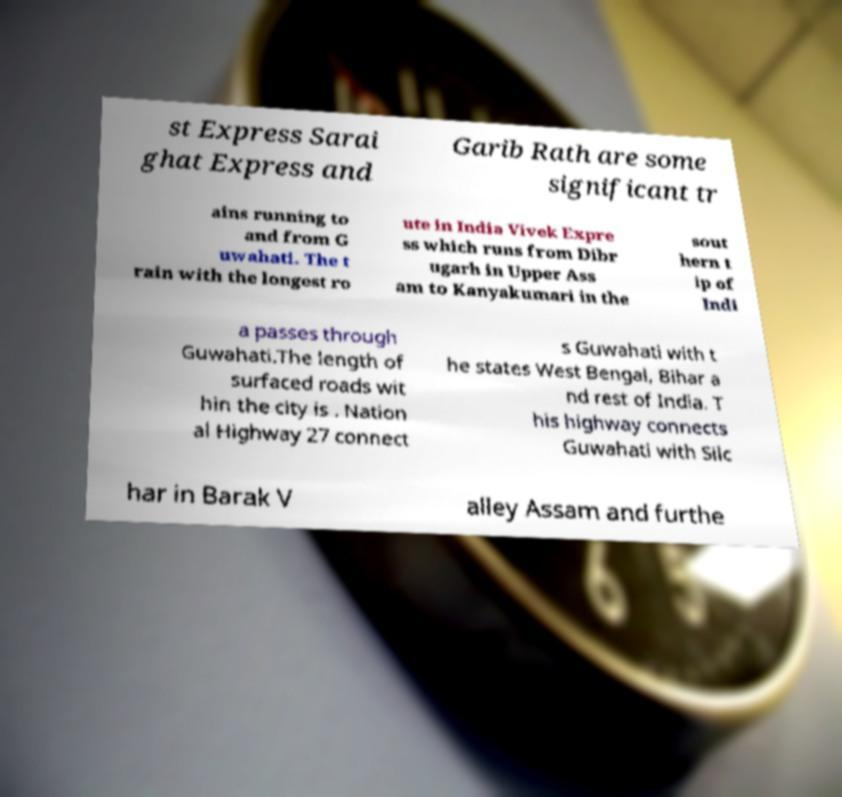I need the written content from this picture converted into text. Can you do that? st Express Sarai ghat Express and Garib Rath are some significant tr ains running to and from G uwahati. The t rain with the longest ro ute in India Vivek Expre ss which runs from Dibr ugarh in Upper Ass am to Kanyakumari in the sout hern t ip of Indi a passes through Guwahati.The length of surfaced roads wit hin the city is . Nation al Highway 27 connect s Guwahati with t he states West Bengal, Bihar a nd rest of India. T his highway connects Guwahati with Silc har in Barak V alley Assam and furthe 